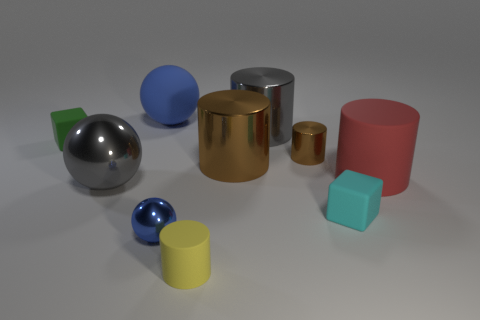Subtract all big shiny spheres. How many spheres are left? 2 Subtract all red cylinders. How many cylinders are left? 4 Subtract all spheres. How many objects are left? 7 Subtract 4 cylinders. How many cylinders are left? 1 Add 2 green metal cylinders. How many green metal cylinders exist? 2 Subtract 0 brown cubes. How many objects are left? 10 Subtract all green spheres. Subtract all gray cylinders. How many spheres are left? 3 Subtract all purple cylinders. How many blue spheres are left? 2 Subtract all tiny metallic objects. Subtract all tiny matte cylinders. How many objects are left? 7 Add 6 small spheres. How many small spheres are left? 7 